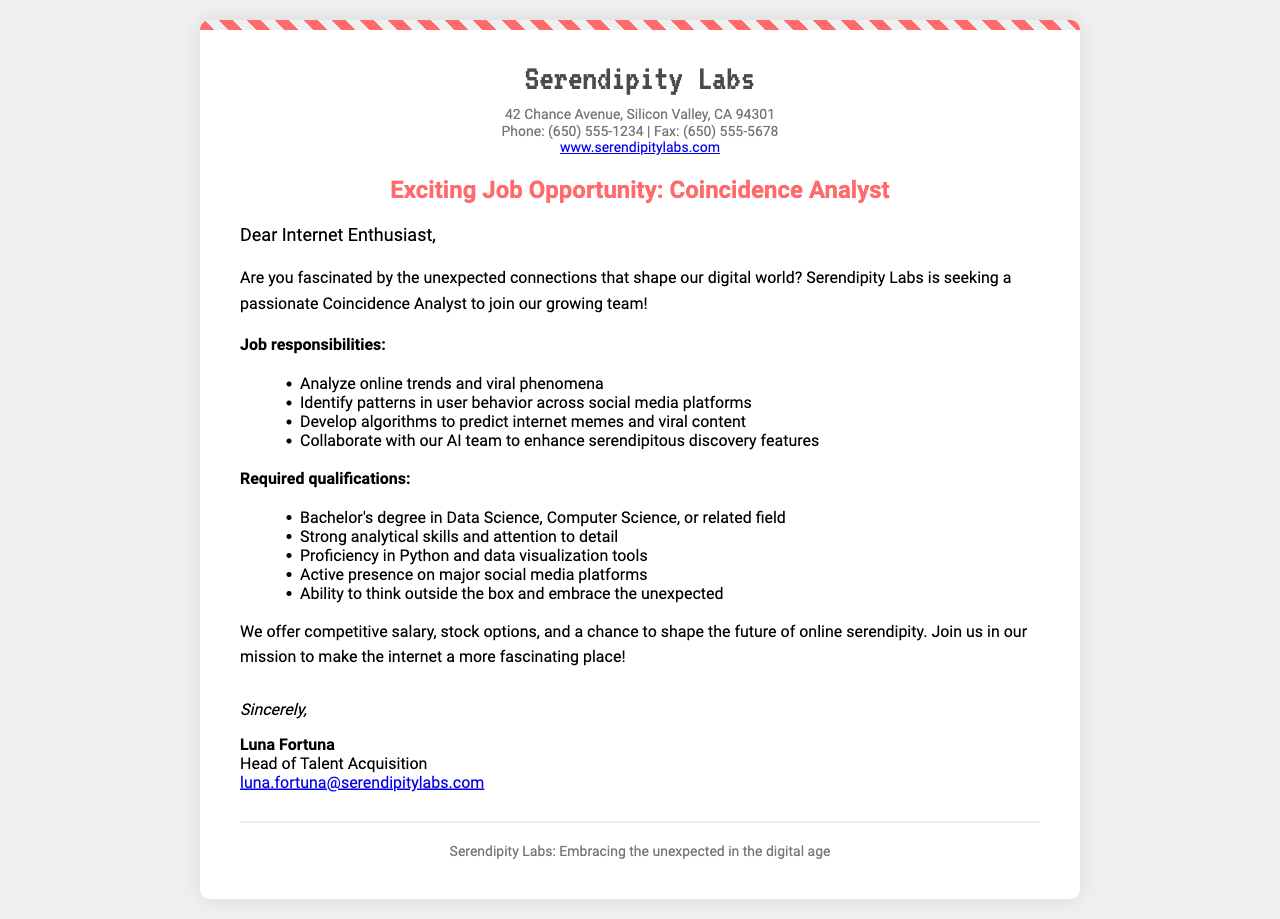What is the company name? The company name is stated prominently at the top of the document.
Answer: Serendipity Labs What is the job title being offered? The job title is clearly mentioned in the subject line of the document.
Answer: Coincidence Analyst What educational qualification is required? The qualifications listed in the document specify education requirements.
Answer: Bachelor's degree What is one of the job responsibilities? The document includes a list of job responsibilities.
Answer: Analyze online trends Who is the Head of Talent Acquisition? The closing section of the document provides the name of the signer.
Answer: Luna Fortuna What is the location of Serendipity Labs? The address is provided in the contact information.
Answer: 42 Chance Avenue, Silicon Valley, CA 94301 What can be expected as part of the compensation? There was a mention of compensation details in the body of the document.
Answer: Stock options What is emphasized as a necessary skill? The qualifications section indicates skills needed for the role.
Answer: Analytical skills How can the applicants contact Luna Fortuna? The document includes contact information for the Head of Talent Acquisition.
Answer: luna.fortuna@serendipitylabs.com 